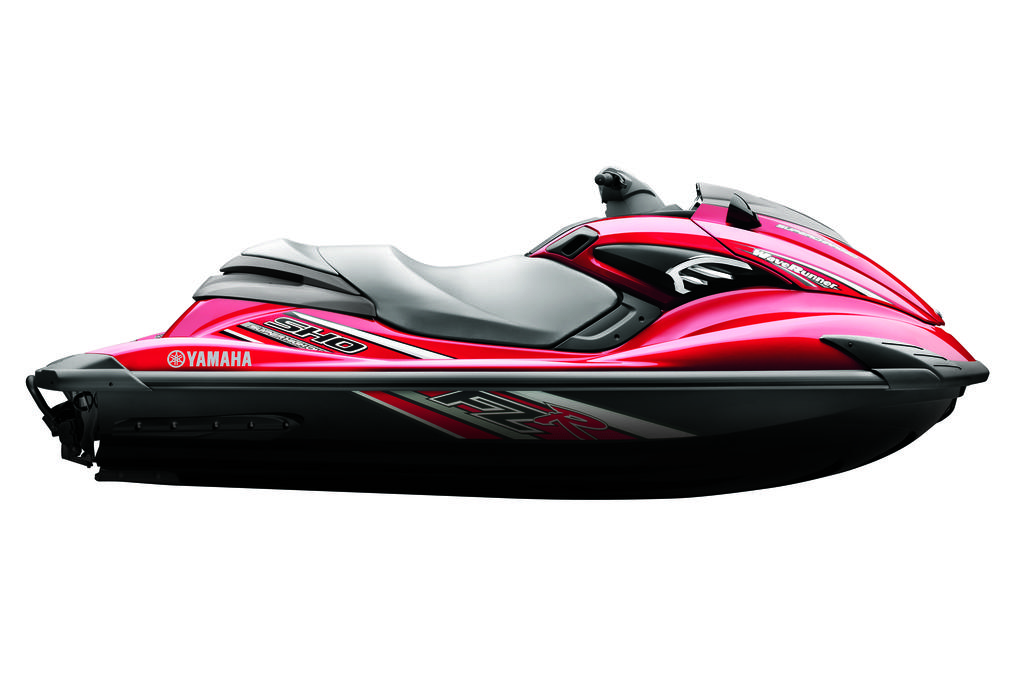What is the main subject of the image? The main subject of the image is a jet ski. Are there any words or letters on the jet ski? Yes, there is text on the jet ski. What color is the background of the image? The background of the image is white in color. What type of reward is being given out on the table in the image? There is no table or reward present in the image; it features a jet ski with text on it against a white background. 